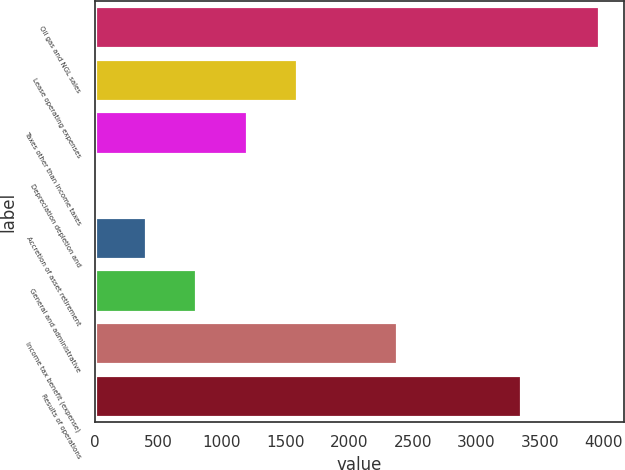Convert chart to OTSL. <chart><loc_0><loc_0><loc_500><loc_500><bar_chart><fcel>Oil gas and NGL sales<fcel>Lease operating expenses<fcel>Taxes other than income taxes<fcel>Depreciation depletion and<fcel>Accretion of asset retirement<fcel>General and administrative<fcel>Income tax benefit (expense)<fcel>Results of operations<nl><fcel>3958<fcel>1587.67<fcel>1192.62<fcel>7.47<fcel>402.52<fcel>797.57<fcel>2377.77<fcel>3350<nl></chart> 